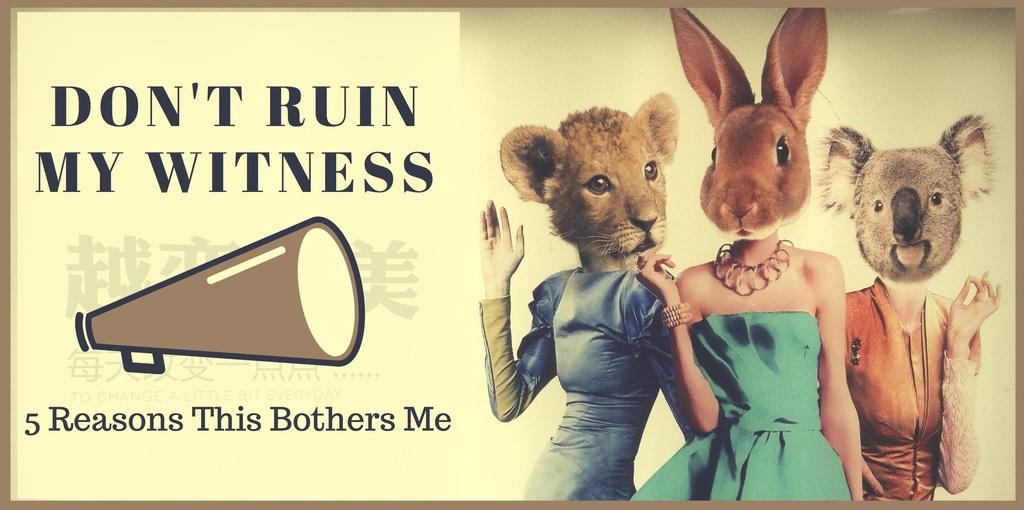What is featured in the image? There is a poster in the image. What can be found on the poster? The poster contains text. Are there any unique elements on the poster? Yes, there are people with animal faces in the poster. What type of memory is being used by the people with animal faces in the image? There is no indication in the image that the people with animal faces are using any specific type of memory. 